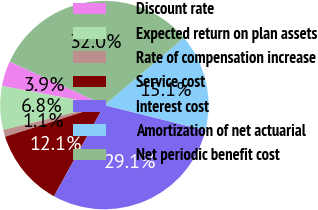<chart> <loc_0><loc_0><loc_500><loc_500><pie_chart><fcel>Discount rate<fcel>Expected return on plan assets<fcel>Rate of compensation increase<fcel>Service cost<fcel>Interest cost<fcel>Amortization of net actuarial<fcel>Net periodic benefit cost<nl><fcel>3.92%<fcel>6.76%<fcel>1.09%<fcel>12.05%<fcel>29.13%<fcel>15.07%<fcel>31.97%<nl></chart> 